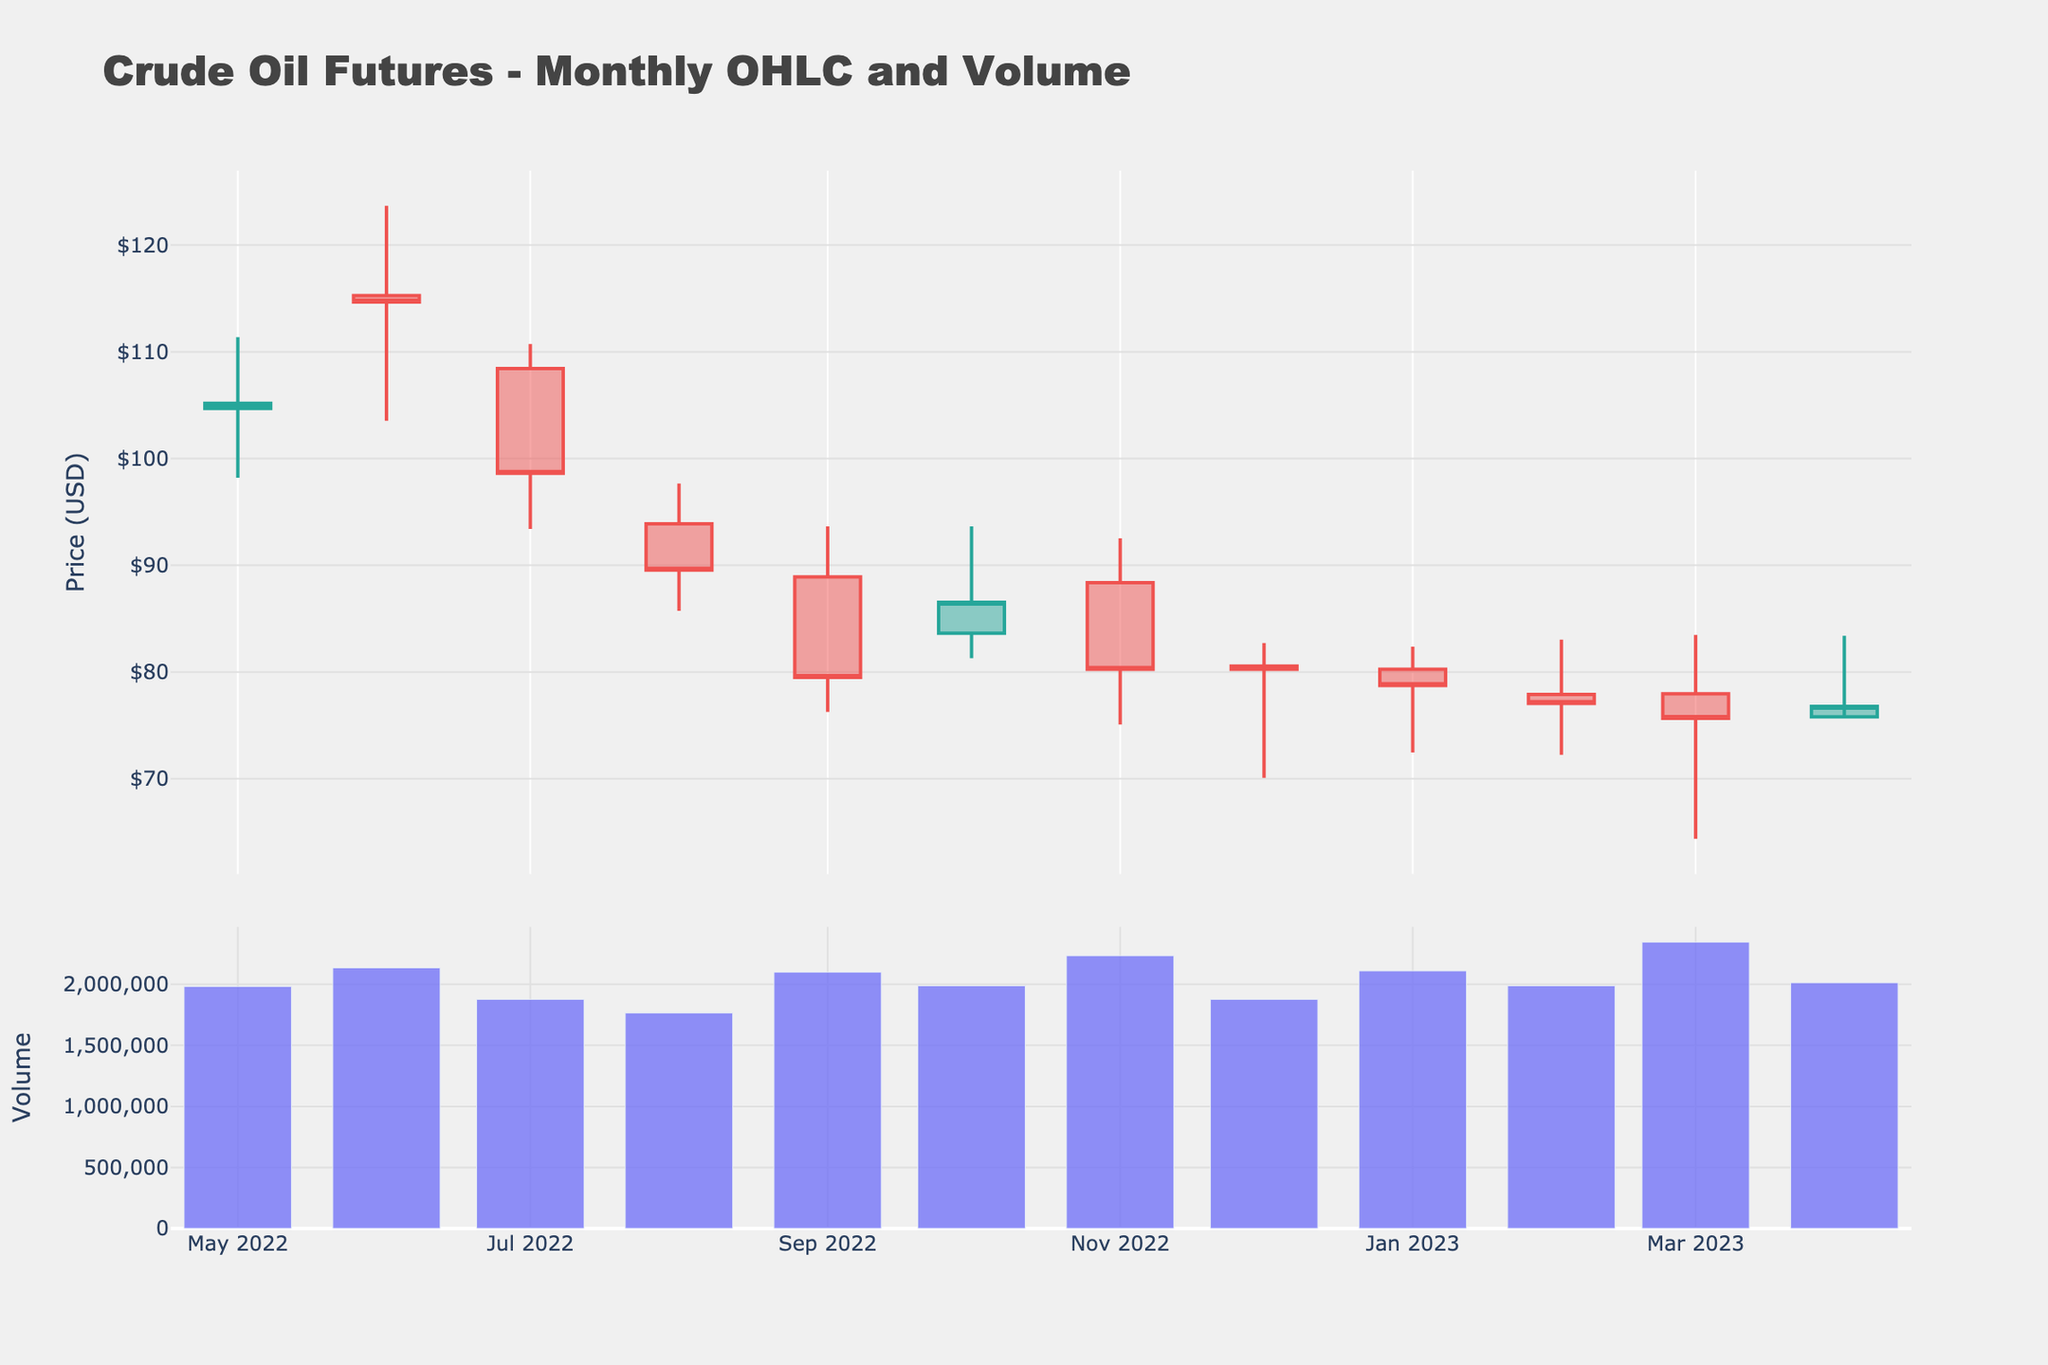what is the title of the plot? The title is usually placed at the top of a figure. By looking at the top area of the figure, we can see the title "Crude Oil Futures - Monthly OHLC and Volume."
Answer: Crude Oil Futures - Monthly OHLC and Volume What does the y-axis on the top subplot represent? The y-axis on the top subplot displays the prices in USD, which can be inferred from the OHLC (Open, High, Low, Close) data represented in the candlestick chart.
Answer: Price (USD) How many months of data are shown in the chart? By counting the data points or bars on the x-axis, each representing a month, we can find that there are 12 months of data presented.
Answer: 12 Which month has the highest trading volume? The volume bars at the bottom subplot represent the trading volume for each month. By identifying the tallest volume bar and referring to its position along the x-axis, we see that March 2023 has the highest trading volume.
Answer: March 2023 In which month did the crude oil price reach its highest level? By examining the highest points of the candlesticks in the top subplot, we see that June 2022 has the highest price, marked by the top of the green candlestick.
Answer: June 2022 What is the overall trend of the crude oil prices from May 2022 to April 2023? The overall trend can be determined by looking at the entire sequence of candlesticks from left (May 2022) to right (April 2023). We observe that the prices generally decrease over this period.
Answer: Decreasing Which month experienced the lowest closing price, and what was the value? By checking the lowest points of the candlestick wicks and looking for the lowest close prices, we find that March 2023 had a closing price of $75.67, which is the lowest in the given range.
Answer: March 2023, $75.67 What is the range of the highest and lowest prices for July 2022? The range can be found by subtracting the lowest price from the highest price of July 2022. The highest price was $110.73 and the lowest was $93.41. So, $110.73 - $93.41 = $17.32.
Answer: $17.32 Which months had more decreasing candles (red) than increasing candles (green)? By visually inspecting the color of the candlesticks, which are represented in green for increasing and red for decreasing, we can count the red ones. July 2022, August 2022, September 2022, November 2022, January 2023, February 2023, March 2023, and April 2023 had more red candlesticks than green.
Answer: July, August, September, November, January, February, March, April What was the average closing price for the entire period displayed? To find the average, we sum all the closing prices and divide by the number of months: (105.17 + 114.67 + 98.62 + 89.55 + 79.49 + 86.53 + 80.26 + 80.26 + 78.74 + 77.05 + 75.67 + 76.78) / 12 = 932.79 / 12 = $77.73.
Answer: $77.73 